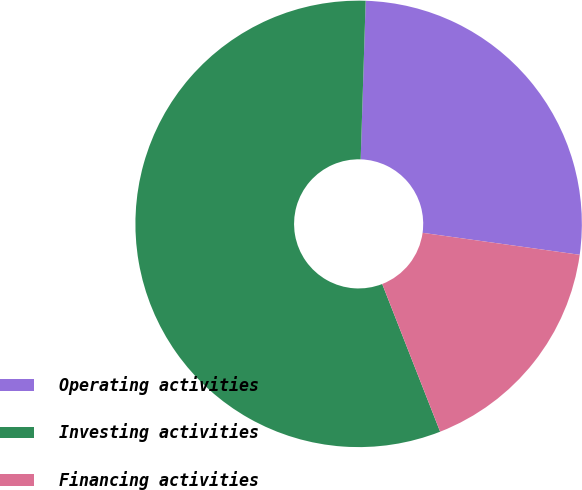<chart> <loc_0><loc_0><loc_500><loc_500><pie_chart><fcel>Operating activities<fcel>Investing activities<fcel>Financing activities<nl><fcel>26.71%<fcel>56.45%<fcel>16.84%<nl></chart> 